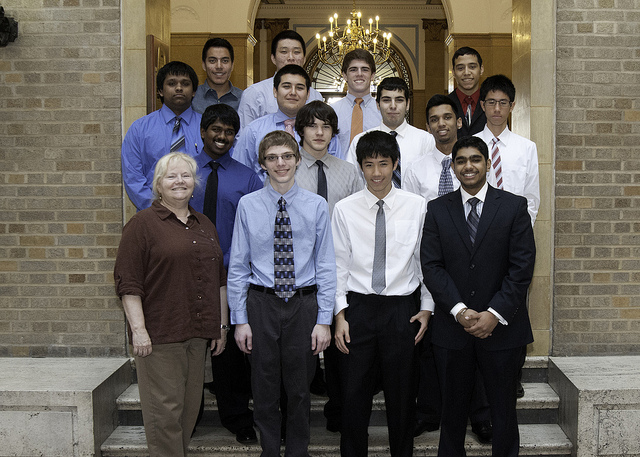<image>What religion does this man represent? It is ambiguous what religion the man represents. It cannot be determined without further information. What religion does this man represent? It is ambiguous what religion does this man represent. He can represent Catholicism, Greek Orthodox, Jewish, Hinduism or none of them. 